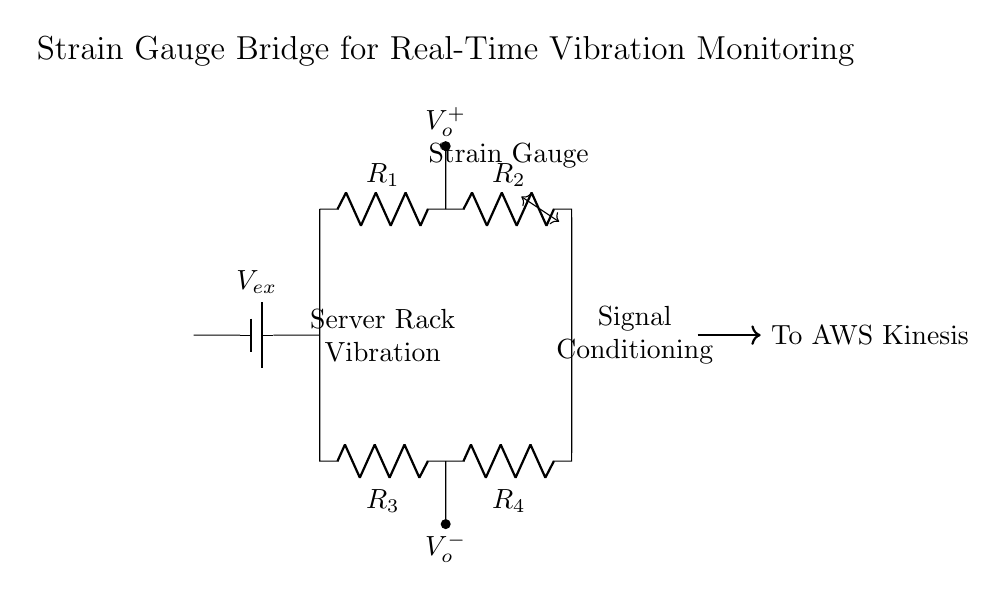What type of circuit is represented here? This is a bridge circuit, specifically a strain gauge bridge, as indicated by the configuration of resistors and the inclusion of a strain gauge component.
Answer: Bridge circuit What is the purpose of the voltage source? The voltage source, labeled as Vex, provides the excitation voltage necessary for the operation of the strain gauge bridge, enabling it to detect changes in resistance due to strain from vibrations.
Answer: Provide excitation voltage What components are in the bridge? The bridge contains four resistors (R1, R2, R3, R4) and one strain gauge, making a total of five components in the circuit configuration.
Answer: Four resistors and one strain gauge What does the output voltage indicate? The output voltage, denoted as Vo, indicates the voltage difference between the two nodes in the bridge, which correlates to the strain experienced by the system due to applied forces or vibrations.
Answer: Strain measurement How does the strain gauge work in this circuit? The strain gauge measures deformations caused by external vibrations which change its resistance, thus affecting the balance of the bridge circuit and altering the output voltage Vo.
Answer: Measures deformations What signal conditioning is implied in the circuit diagram? The diagram indicates that the output voltage Vo will undergo signal conditioning to filter and amplify the signal before sending it for further processing, typically for accurate analysis in real-time applications.
Answer: Signal amplification and filtering Where does the output data go? The data flows to AWS Kinesis, as shown by the directional arrow indicating that the processed signal will be sent to the specified streaming service for real-time analytics.
Answer: To AWS Kinesis 